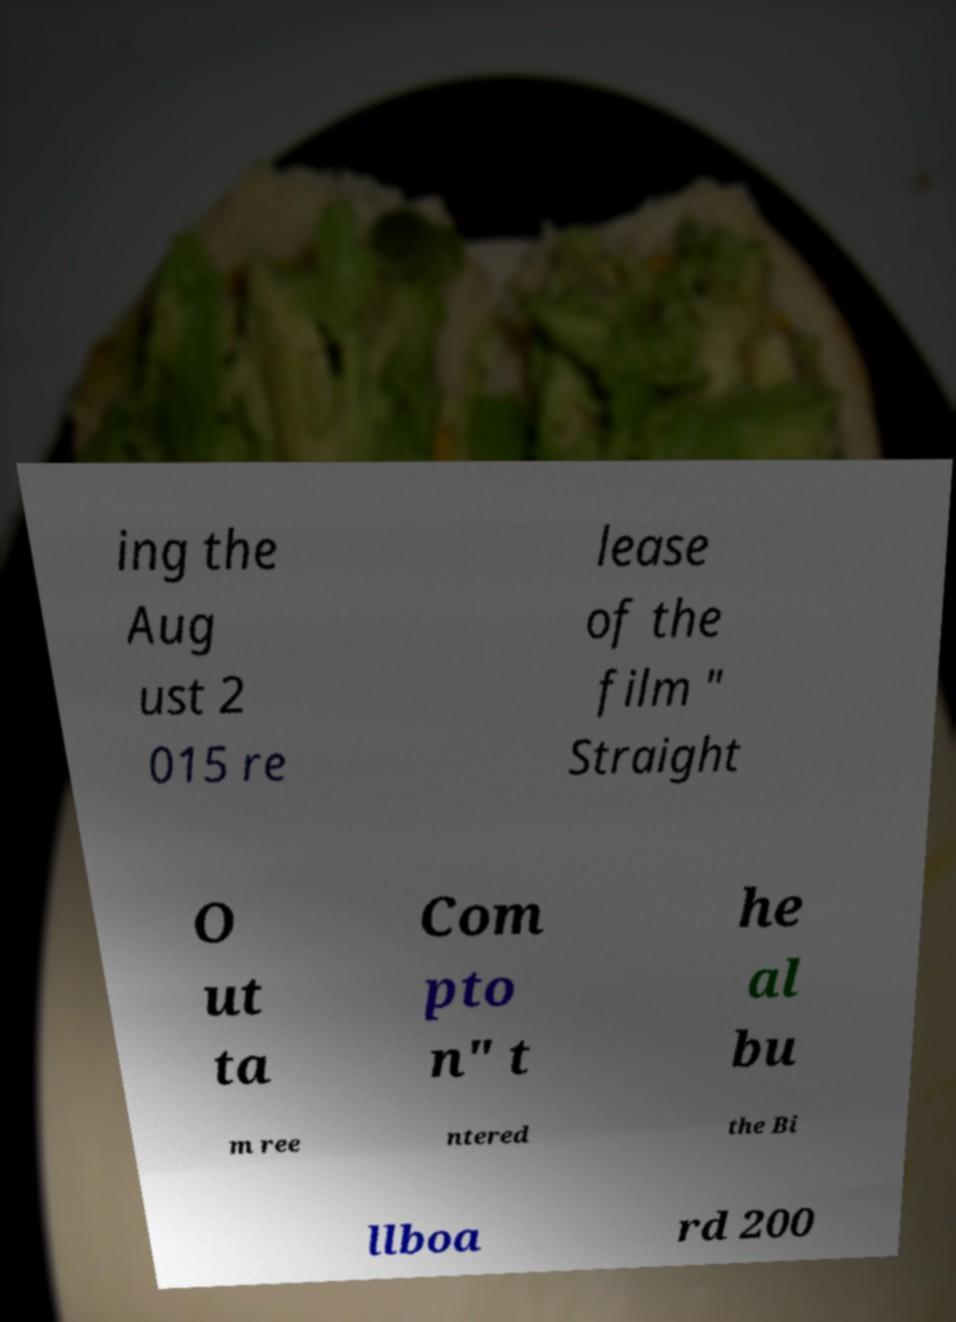I need the written content from this picture converted into text. Can you do that? ing the Aug ust 2 015 re lease of the film " Straight O ut ta Com pto n" t he al bu m ree ntered the Bi llboa rd 200 